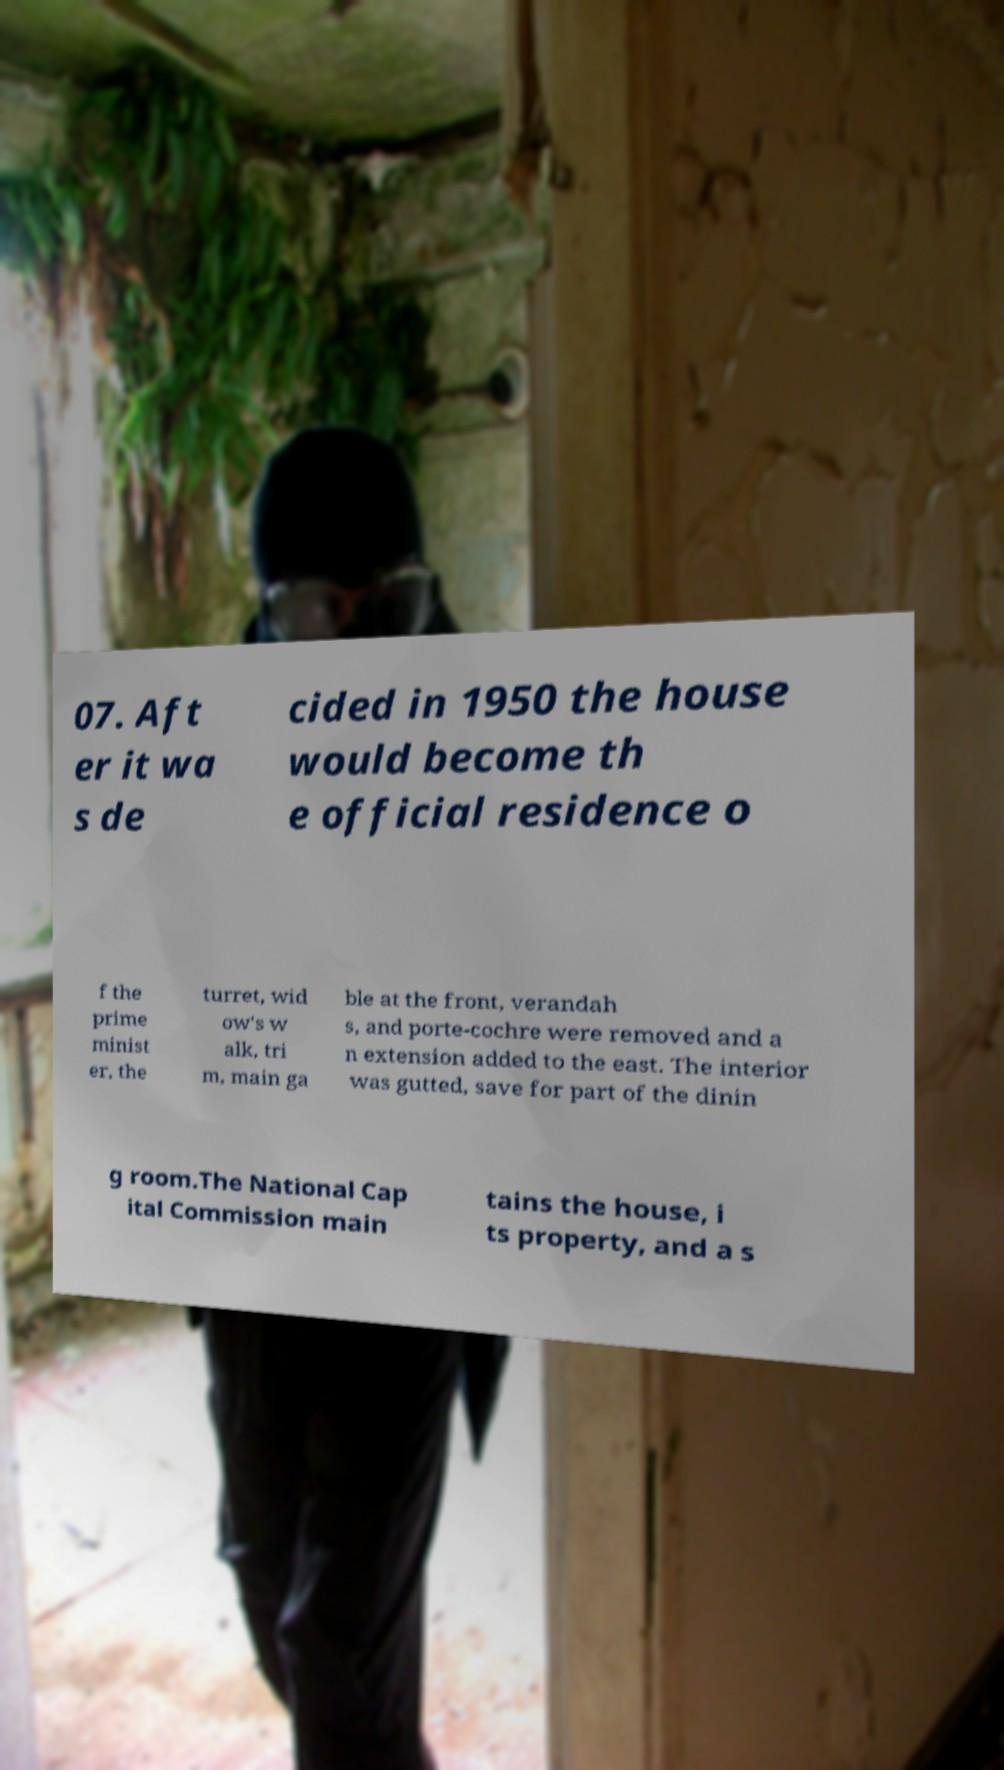Please read and relay the text visible in this image. What does it say? 07. Aft er it wa s de cided in 1950 the house would become th e official residence o f the prime minist er, the turret, wid ow's w alk, tri m, main ga ble at the front, verandah s, and porte-cochre were removed and a n extension added to the east. The interior was gutted, save for part of the dinin g room.The National Cap ital Commission main tains the house, i ts property, and a s 